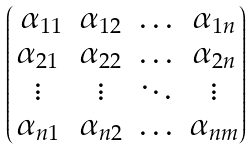<formula> <loc_0><loc_0><loc_500><loc_500>\begin{pmatrix} \ \alpha _ { 1 1 } & \alpha _ { 1 2 } & \hdots & \alpha _ { 1 n } \\ \alpha _ { 2 1 } & \alpha _ { 2 2 } & \hdots & \alpha _ { 2 n } \\ \vdots & \vdots & \ddots & \vdots \\ \alpha _ { n 1 } & \alpha _ { n 2 } & \hdots & \alpha _ { n m } \end{pmatrix}</formula> 